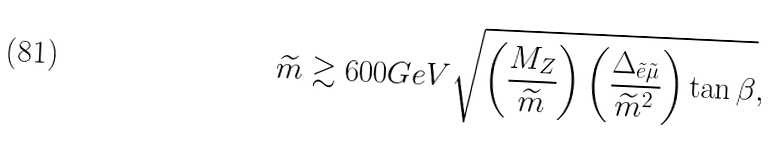Convert formula to latex. <formula><loc_0><loc_0><loc_500><loc_500>\widetilde { m } \gtrsim 6 0 0 { G e V } \sqrt { \left ( \frac { M _ { Z } } { \widetilde { m } } \right ) \left ( \frac { \Delta _ { \tilde { e } \tilde { \mu } } } { \widetilde { m } ^ { 2 } } \right ) \tan \beta } ,</formula> 